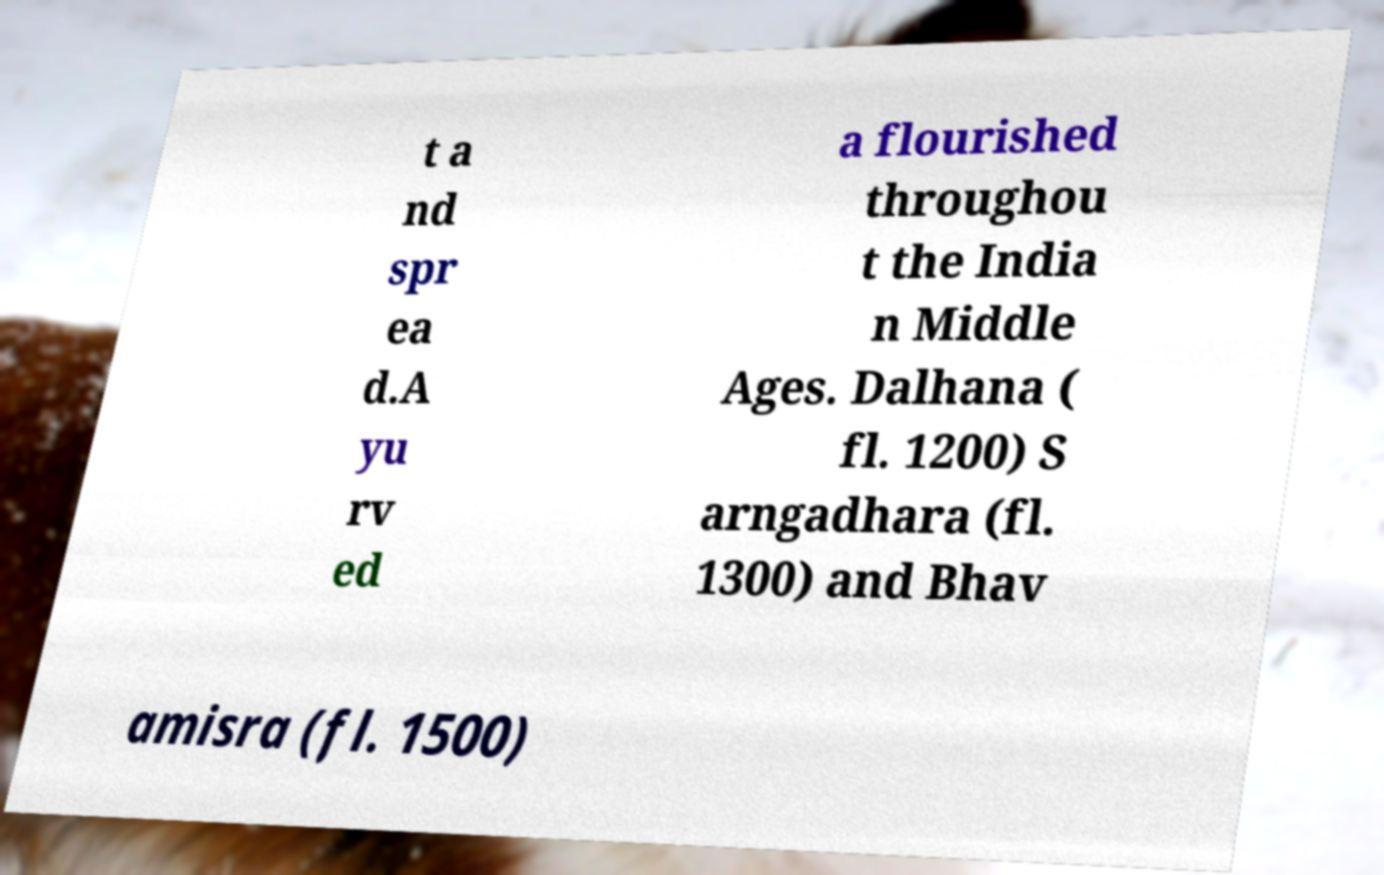Could you extract and type out the text from this image? t a nd spr ea d.A yu rv ed a flourished throughou t the India n Middle Ages. Dalhana ( fl. 1200) S arngadhara (fl. 1300) and Bhav amisra (fl. 1500) 